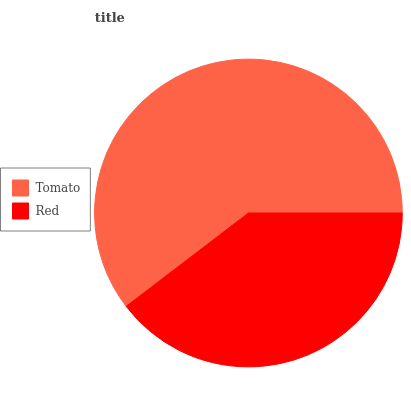Is Red the minimum?
Answer yes or no. Yes. Is Tomato the maximum?
Answer yes or no. Yes. Is Red the maximum?
Answer yes or no. No. Is Tomato greater than Red?
Answer yes or no. Yes. Is Red less than Tomato?
Answer yes or no. Yes. Is Red greater than Tomato?
Answer yes or no. No. Is Tomato less than Red?
Answer yes or no. No. Is Tomato the high median?
Answer yes or no. Yes. Is Red the low median?
Answer yes or no. Yes. Is Red the high median?
Answer yes or no. No. Is Tomato the low median?
Answer yes or no. No. 